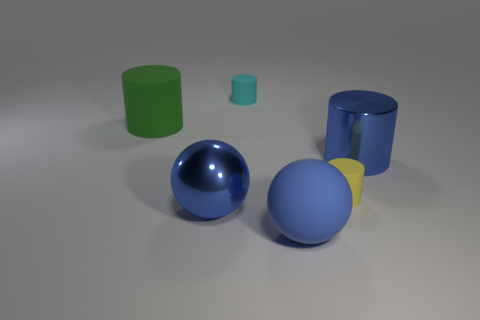Add 2 small green blocks. How many objects exist? 8 Subtract all tiny cyan matte cylinders. How many cylinders are left? 3 Subtract all cyan cylinders. How many cylinders are left? 3 Subtract all cylinders. How many objects are left? 2 Subtract 1 cylinders. How many cylinders are left? 3 Subtract all gray cylinders. How many red balls are left? 0 Subtract all gray matte cylinders. Subtract all tiny cyan rubber objects. How many objects are left? 5 Add 3 blue objects. How many blue objects are left? 6 Add 1 tiny yellow metal objects. How many tiny yellow metal objects exist? 1 Subtract 1 green cylinders. How many objects are left? 5 